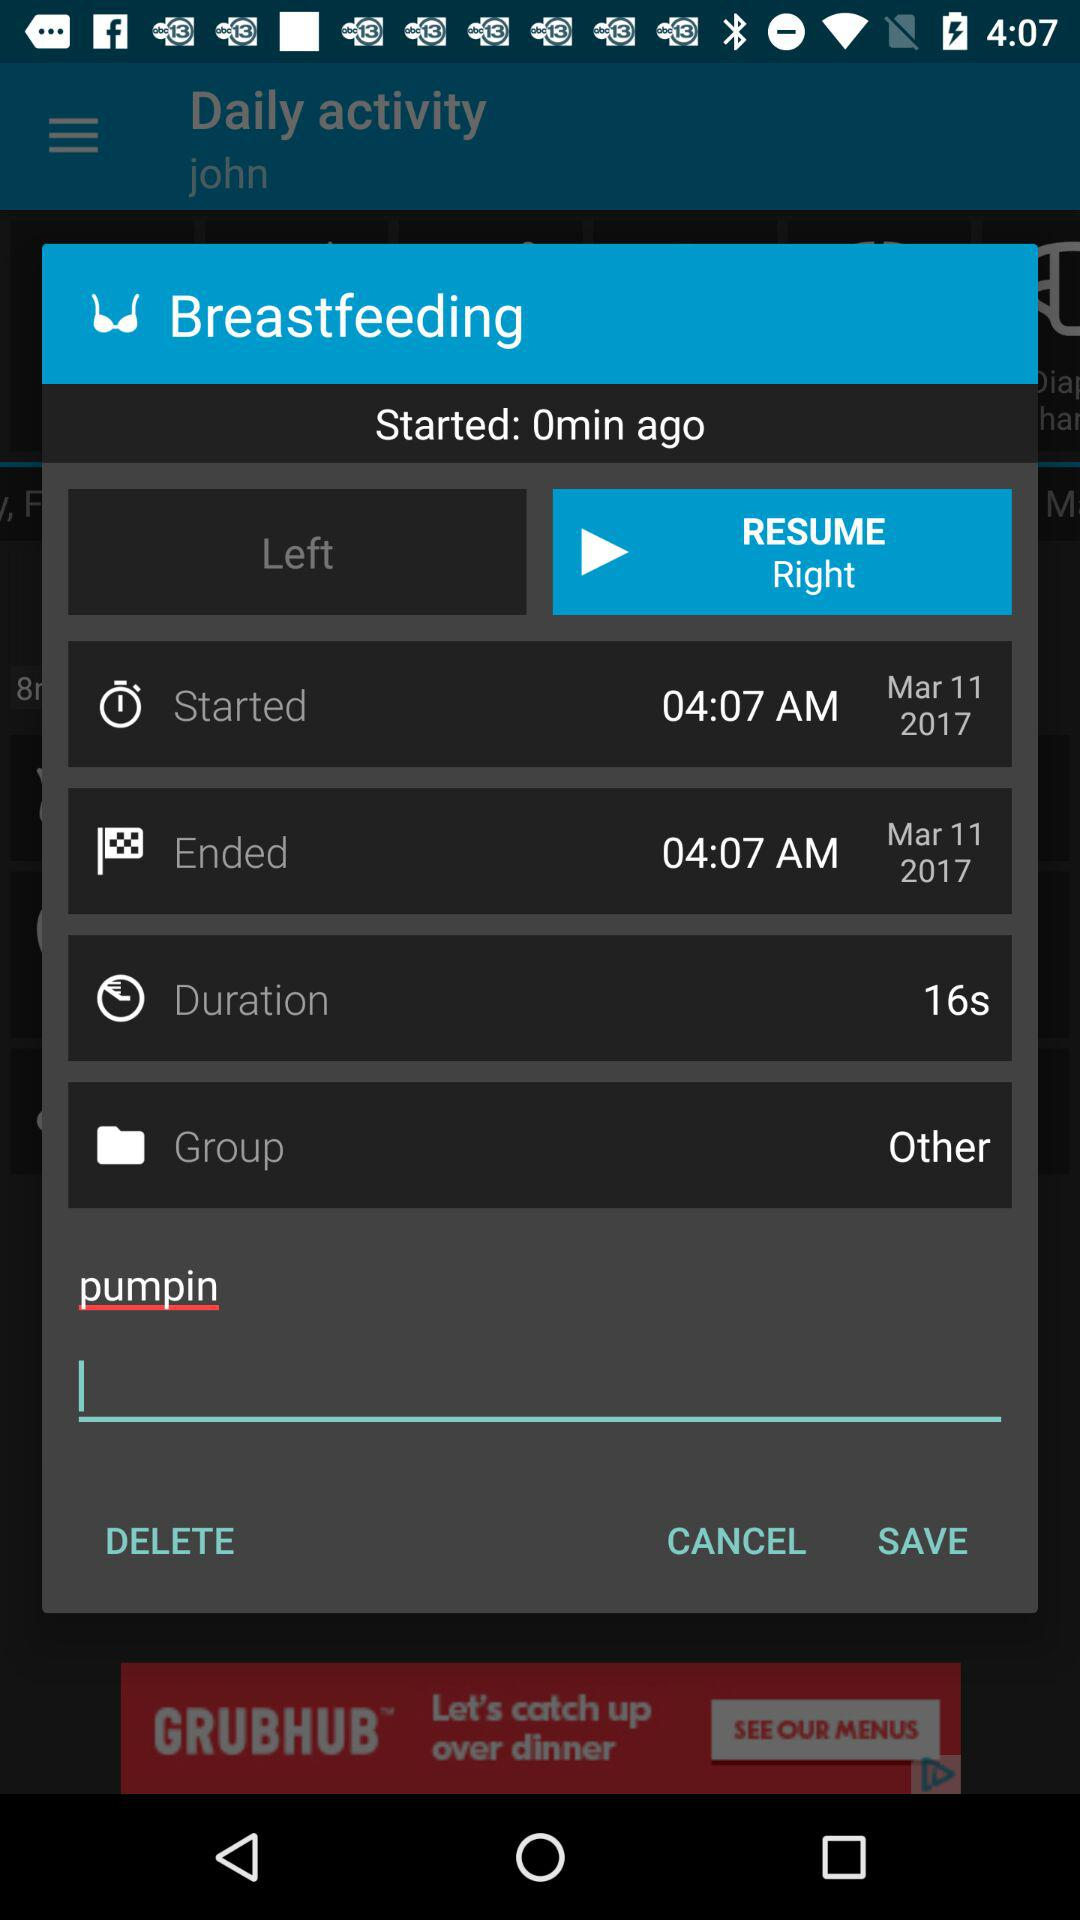How long was the session?
Answer the question using a single word or phrase. 16s 